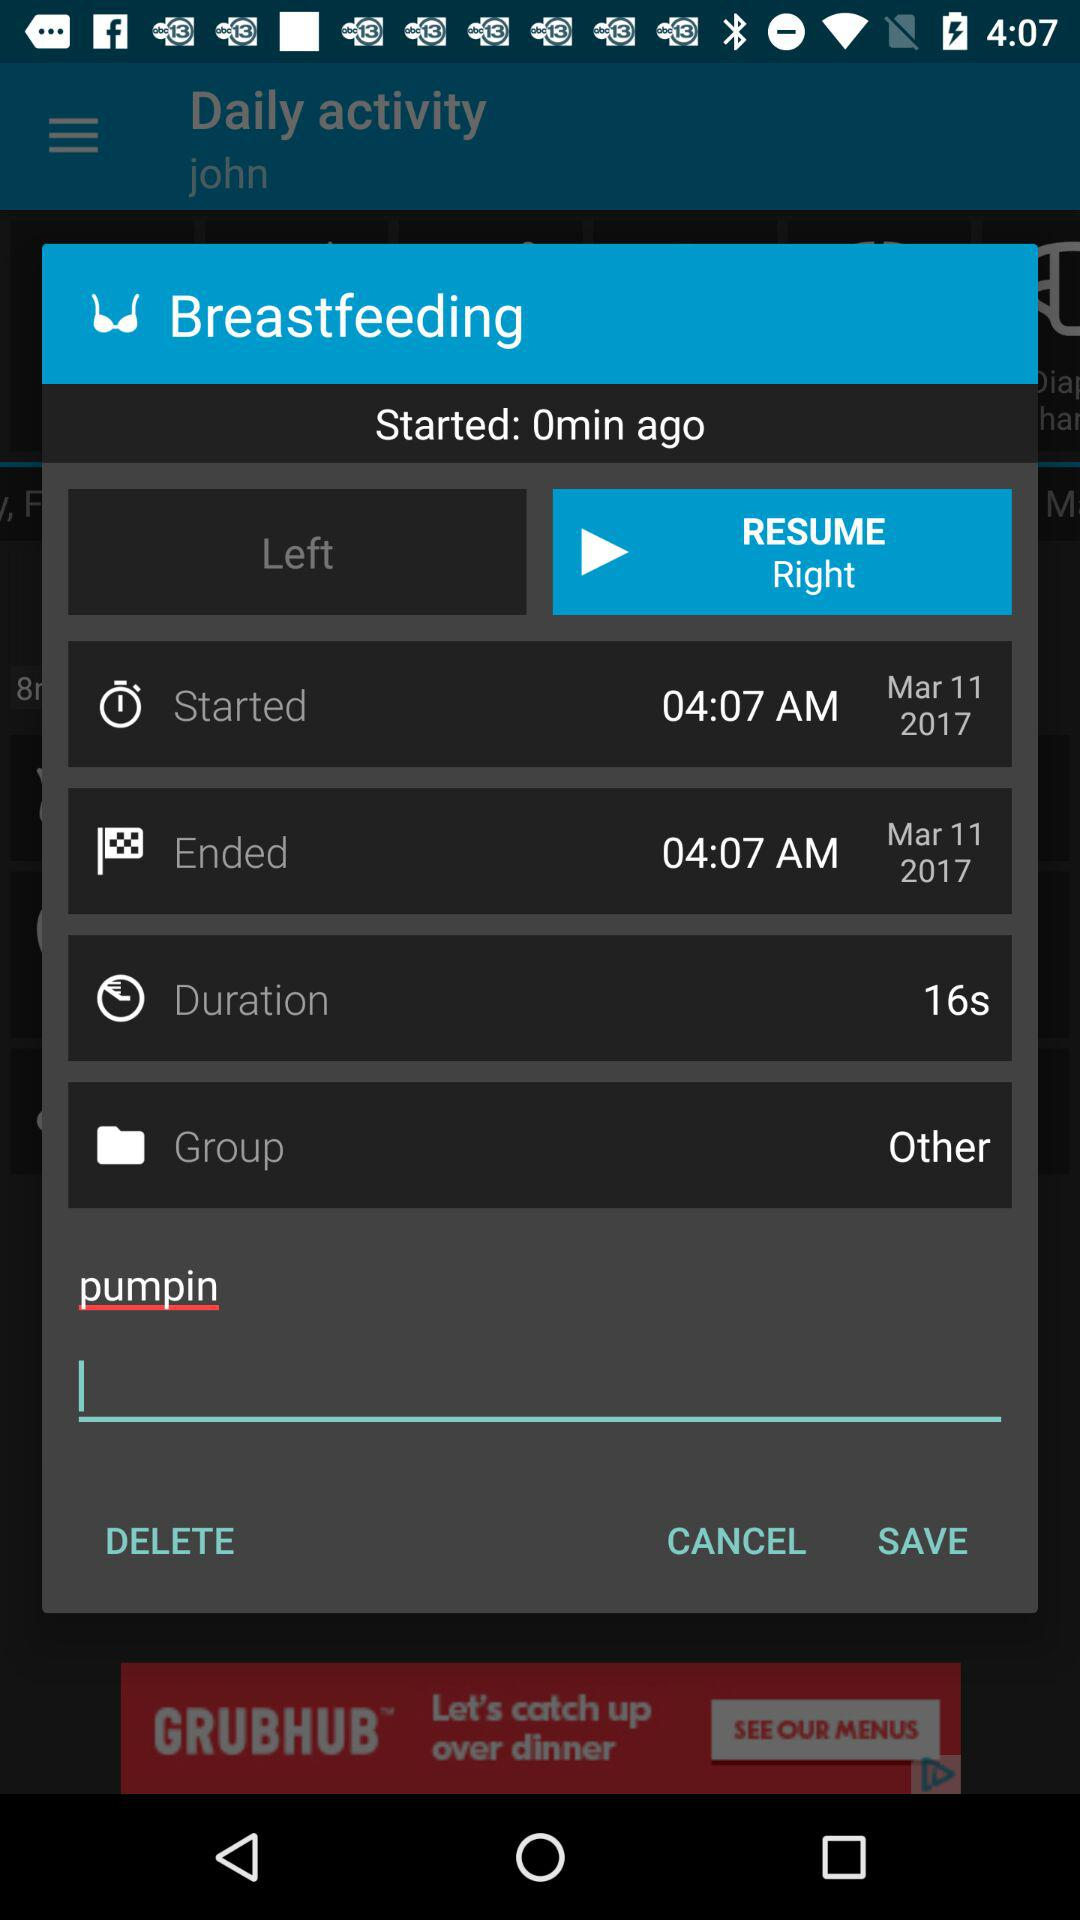How long was the session?
Answer the question using a single word or phrase. 16s 